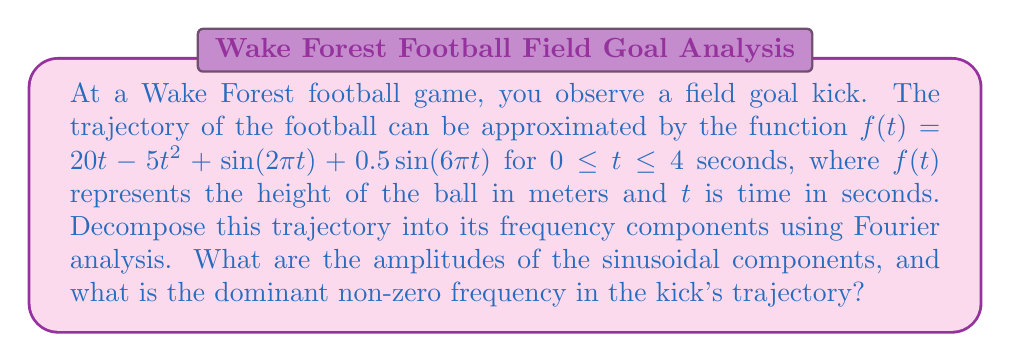Teach me how to tackle this problem. Let's approach this step-by-step:

1) The given function $f(t) = 20t - 5t^2 + \sin(2\pi t) + 0.5\sin(6\pi t)$ can be separated into two parts:
   - Non-periodic part: $20t - 5t^2$
   - Periodic part: $\sin(2\pi t) + 0.5\sin(6\pi t)$

2) The Fourier transform focuses on the periodic part. We can identify two sinusoidal components:
   - $\sin(2\pi t)$ with amplitude 1 and frequency 1 Hz
   - $0.5\sin(6\pi t)$ with amplitude 0.5 and frequency 3 Hz

3) To find the amplitudes, we look at the coefficients:
   - For $\sin(2\pi t)$, the amplitude is 1
   - For $0.5\sin(6\pi t)$, the amplitude is 0.5

4) The frequencies are:
   - For $\sin(2\pi t)$: $f_1 = \frac{\omega_1}{2\pi} = \frac{2\pi}{2\pi} = 1$ Hz
   - For $0.5\sin(6\pi t)$: $f_2 = \frac{\omega_2}{2\pi} = \frac{6\pi}{2\pi} = 3$ Hz

5) The dominant non-zero frequency is the one with the largest amplitude. In this case, it's 1 Hz, corresponding to $\sin(2\pi t)$.

The non-periodic part $20t - 5t^2$ would contribute to the DC (zero frequency) component and very low-frequency components in a full Fourier analysis, but it doesn't affect our identification of the sinusoidal components.
Answer: The amplitudes of the sinusoidal components are 1 and 0.5. The dominant non-zero frequency in the kick's trajectory is 1 Hz. 